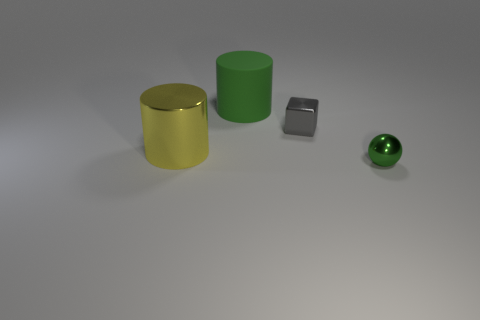Add 2 tiny cyan metal objects. How many objects exist? 6 Subtract all blocks. How many objects are left? 3 Subtract all large blue cylinders. Subtract all tiny gray shiny blocks. How many objects are left? 3 Add 4 metallic cubes. How many metallic cubes are left? 5 Add 2 big yellow objects. How many big yellow objects exist? 3 Subtract 0 purple balls. How many objects are left? 4 Subtract all yellow cylinders. Subtract all purple blocks. How many cylinders are left? 1 